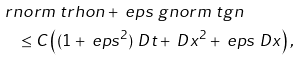Convert formula to latex. <formula><loc_0><loc_0><loc_500><loc_500>& \ r n o r m { \ t r h o n } + \ e p s \ g n o r m { \ t g n } \\ & \quad \leq C \left ( ( 1 + \ e p s ^ { 2 } ) \ D t + \ D x ^ { 2 } + \ e p s \ D x \right ) ,</formula> 